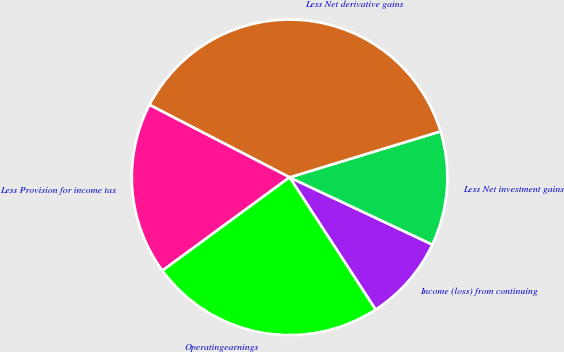Convert chart to OTSL. <chart><loc_0><loc_0><loc_500><loc_500><pie_chart><fcel>Income (loss) from continuing<fcel>Less Net investment gains<fcel>Less Net derivative gains<fcel>Less Provision for income tax<fcel>Operatingearnings<nl><fcel>8.82%<fcel>11.71%<fcel>37.7%<fcel>17.67%<fcel>24.1%<nl></chart> 